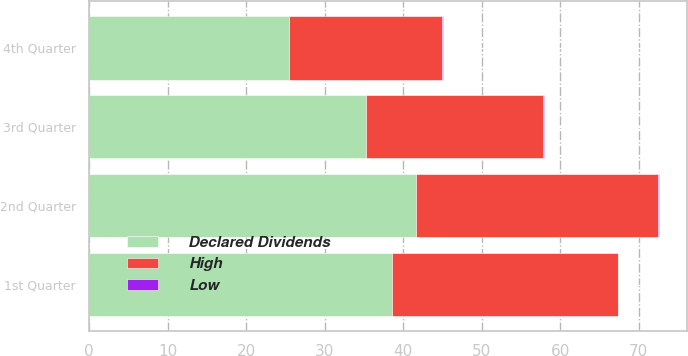Convert chart. <chart><loc_0><loc_0><loc_500><loc_500><stacked_bar_chart><ecel><fcel>1st Quarter<fcel>2nd Quarter<fcel>3rd Quarter<fcel>4th Quarter<nl><fcel>Declared Dividends<fcel>38.56<fcel>41.66<fcel>35.27<fcel>25.43<nl><fcel>High<fcel>28.78<fcel>30.8<fcel>22.55<fcel>19.52<nl><fcel>Low<fcel>0.09<fcel>0.1<fcel>0.1<fcel>0.15<nl></chart> 